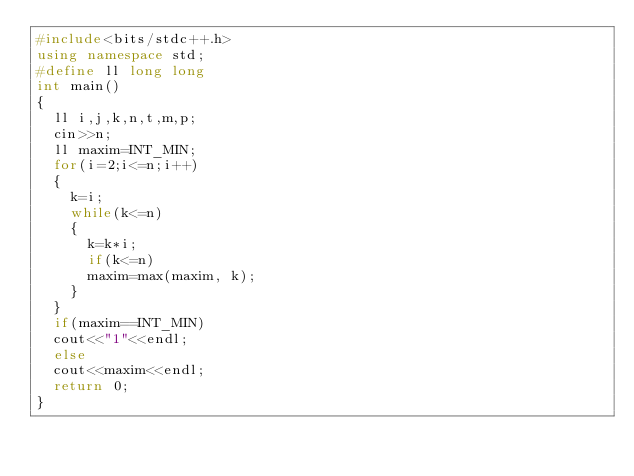Convert code to text. <code><loc_0><loc_0><loc_500><loc_500><_C++_>#include<bits/stdc++.h>
using namespace std;
#define ll long long
int main()
{
	ll i,j,k,n,t,m,p;
	cin>>n;
	ll maxim=INT_MIN;
	for(i=2;i<=n;i++)
	{
		k=i;
		while(k<=n)
		{
			k=k*i;
			if(k<=n)
			maxim=max(maxim, k);
		}
	}
	if(maxim==INT_MIN)
	cout<<"1"<<endl;
	else
	cout<<maxim<<endl;
	return 0;
}</code> 